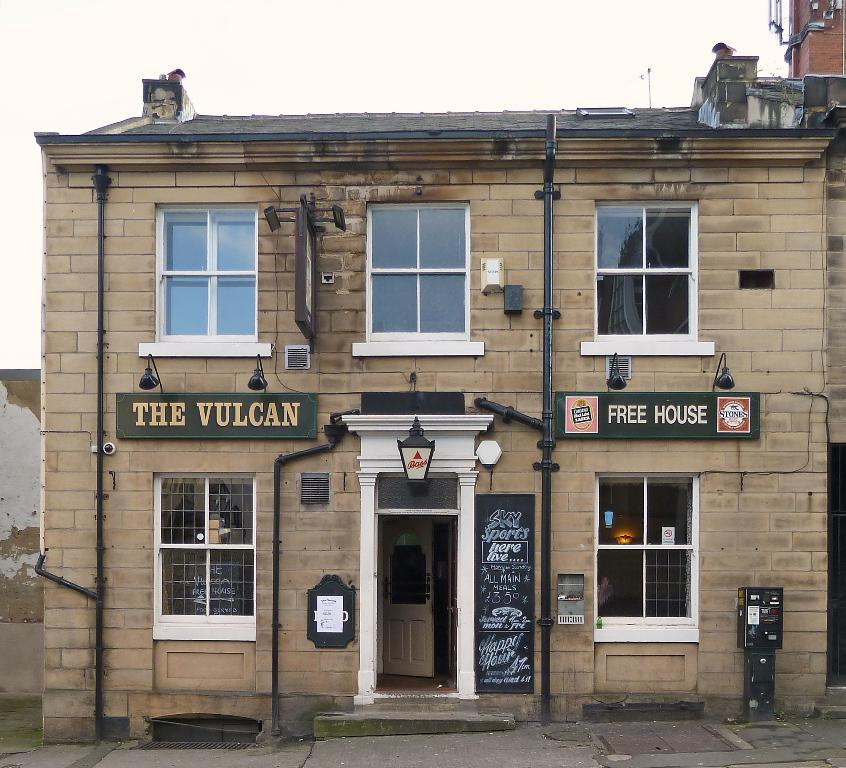What type of windows does the building have? The building has glass windows. What is on top of the building? The building has a roof. What is displayed on the walls of the building? There are hoardings on the walls of the building. What can be seen behind the building? There is a wall and another building in the background. What is visible in the sky in the background? The sky is visible in the background. How many holes are there in the building's roof? There is no mention of any holes in the building's roof in the image. 